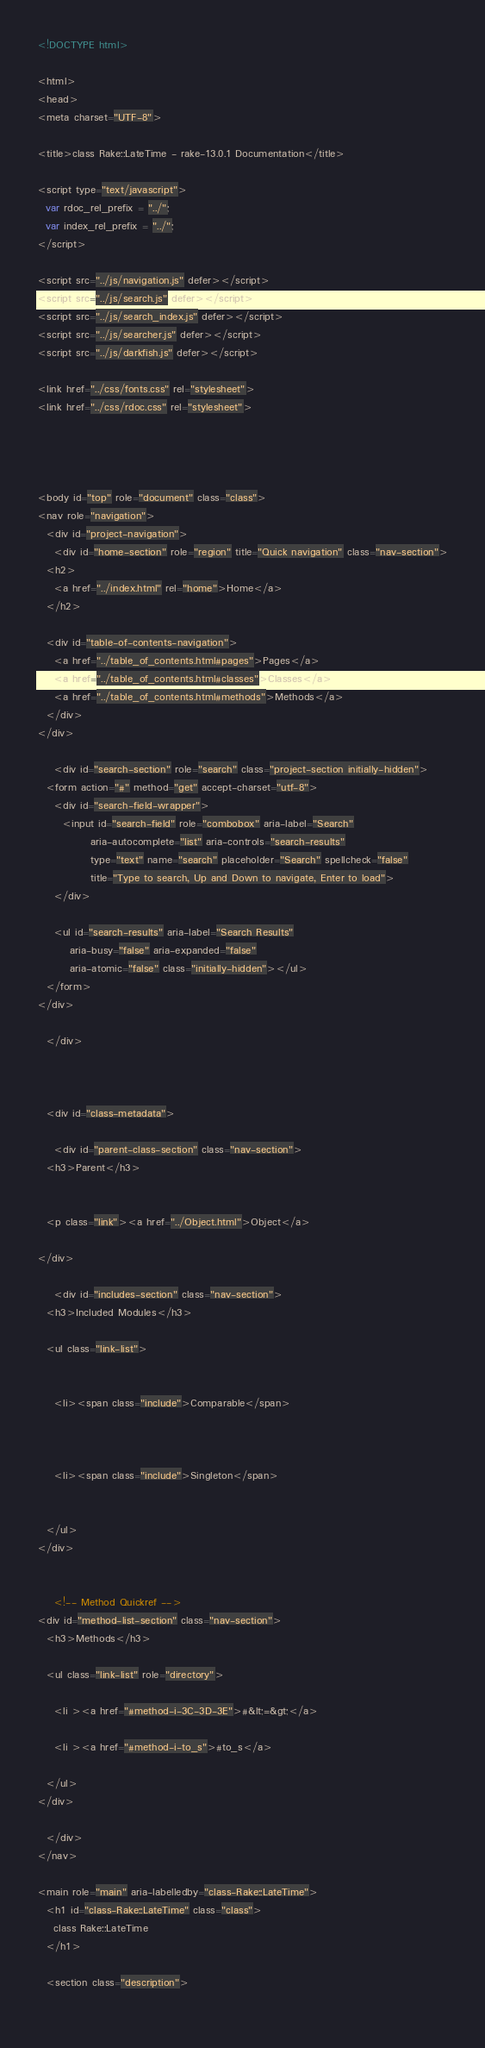<code> <loc_0><loc_0><loc_500><loc_500><_HTML_><!DOCTYPE html>

<html>
<head>
<meta charset="UTF-8">

<title>class Rake::LateTime - rake-13.0.1 Documentation</title>

<script type="text/javascript">
  var rdoc_rel_prefix = "../";
  var index_rel_prefix = "../";
</script>

<script src="../js/navigation.js" defer></script>
<script src="../js/search.js" defer></script>
<script src="../js/search_index.js" defer></script>
<script src="../js/searcher.js" defer></script>
<script src="../js/darkfish.js" defer></script>

<link href="../css/fonts.css" rel="stylesheet">
<link href="../css/rdoc.css" rel="stylesheet">




<body id="top" role="document" class="class">
<nav role="navigation">
  <div id="project-navigation">
    <div id="home-section" role="region" title="Quick navigation" class="nav-section">
  <h2>
    <a href="../index.html" rel="home">Home</a>
  </h2>

  <div id="table-of-contents-navigation">
    <a href="../table_of_contents.html#pages">Pages</a>
    <a href="../table_of_contents.html#classes">Classes</a>
    <a href="../table_of_contents.html#methods">Methods</a>
  </div>
</div>

    <div id="search-section" role="search" class="project-section initially-hidden">
  <form action="#" method="get" accept-charset="utf-8">
    <div id="search-field-wrapper">
      <input id="search-field" role="combobox" aria-label="Search"
             aria-autocomplete="list" aria-controls="search-results"
             type="text" name="search" placeholder="Search" spellcheck="false"
             title="Type to search, Up and Down to navigate, Enter to load">
    </div>

    <ul id="search-results" aria-label="Search Results"
        aria-busy="false" aria-expanded="false"
        aria-atomic="false" class="initially-hidden"></ul>
  </form>
</div>

  </div>

  

  <div id="class-metadata">
    
    <div id="parent-class-section" class="nav-section">
  <h3>Parent</h3>

  
  <p class="link"><a href="../Object.html">Object</a>
  
</div>

    <div id="includes-section" class="nav-section">
  <h3>Included Modules</h3>

  <ul class="link-list">
  
  
    <li><span class="include">Comparable</span>
  
  
  
    <li><span class="include">Singleton</span>
  
  
  </ul>
</div>

    
    <!-- Method Quickref -->
<div id="method-list-section" class="nav-section">
  <h3>Methods</h3>

  <ul class="link-list" role="directory">
    
    <li ><a href="#method-i-3C-3D-3E">#&lt;=&gt;</a>
    
    <li ><a href="#method-i-to_s">#to_s</a>
    
  </ul>
</div>

  </div>
</nav>

<main role="main" aria-labelledby="class-Rake::LateTime">
  <h1 id="class-Rake::LateTime" class="class">
    class Rake::LateTime
  </h1>

  <section class="description">
    </code> 